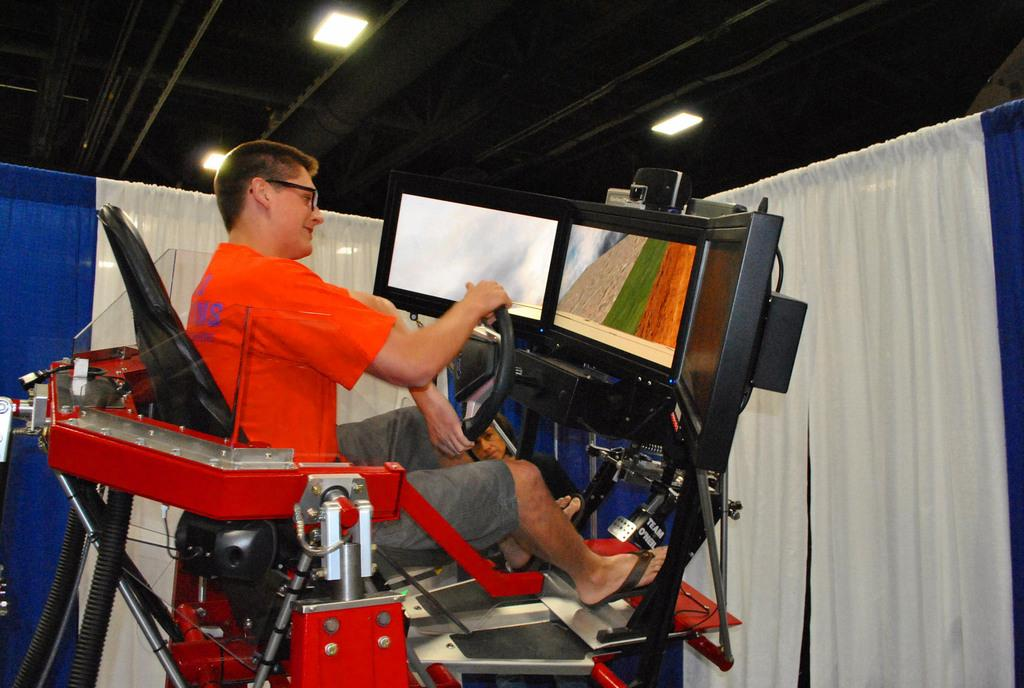What is the main subject of the image? There is a man in the image. What is the man doing in the image? The man is sitting on a machine and holding a steering. What is in front of the man? There are screens and curtains in front of the man. What type of lighting is visible in the image? There are ceiling lights visible in the image. What type of reaction does the man have to the basket in the image? There is no basket present in the image, so it is not possible to determine the man's reaction to it. What is the man biting in the image? There is no indication in the image that the man is biting anything. 